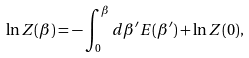Convert formula to latex. <formula><loc_0><loc_0><loc_500><loc_500>\ln Z ( \beta ) = - \int _ { 0 } ^ { \beta } d \beta ^ { \prime } E ( \beta ^ { \prime } ) + \ln Z ( 0 ) ,</formula> 